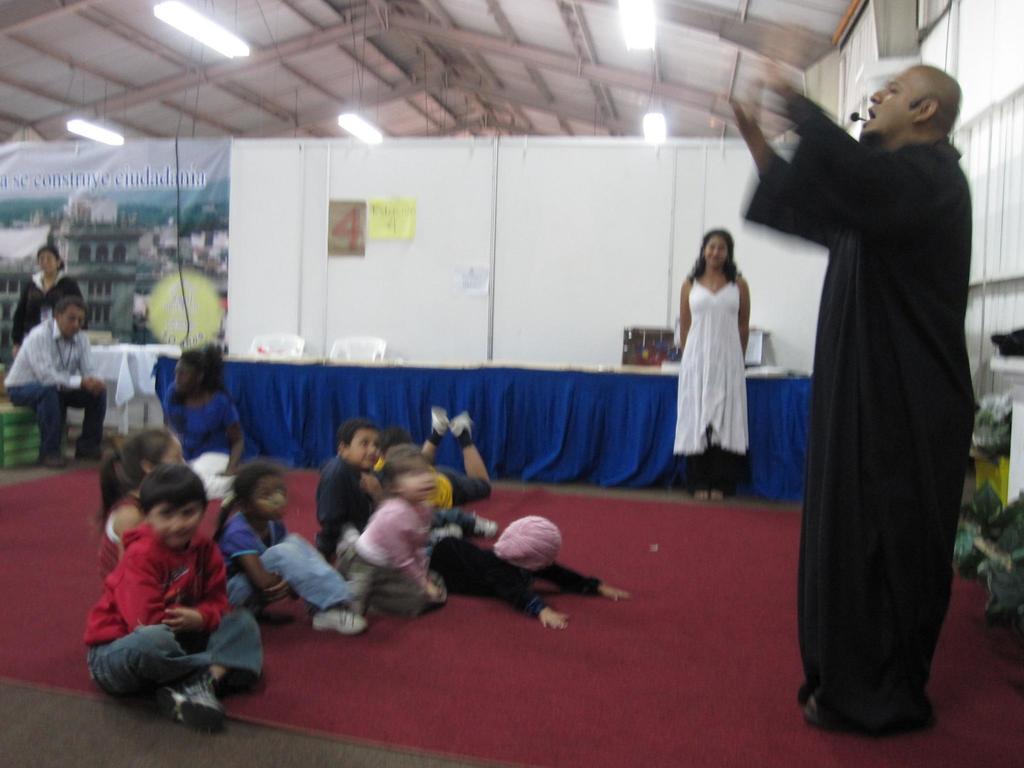Describe this image in one or two sentences. On the right side, we see a man is standing. I think he is talking on the microphone. Behind him, we see the objects in black, green and yellow color. In the middle, we see the children are sitting on the red carpet. On the left side, we see a man is sitting on the green stool. Behind him, we see a woman is standing. In the background, we see a woman in the white dress is stunning. Behind her, we see a table which is covered with a blue color cloth. Behind that, we see the chairs and the boards. In the background, we see a white wall on which some posts are posted. On the left side, we see a banner. At the top, we see the lights and the roof of the building. 